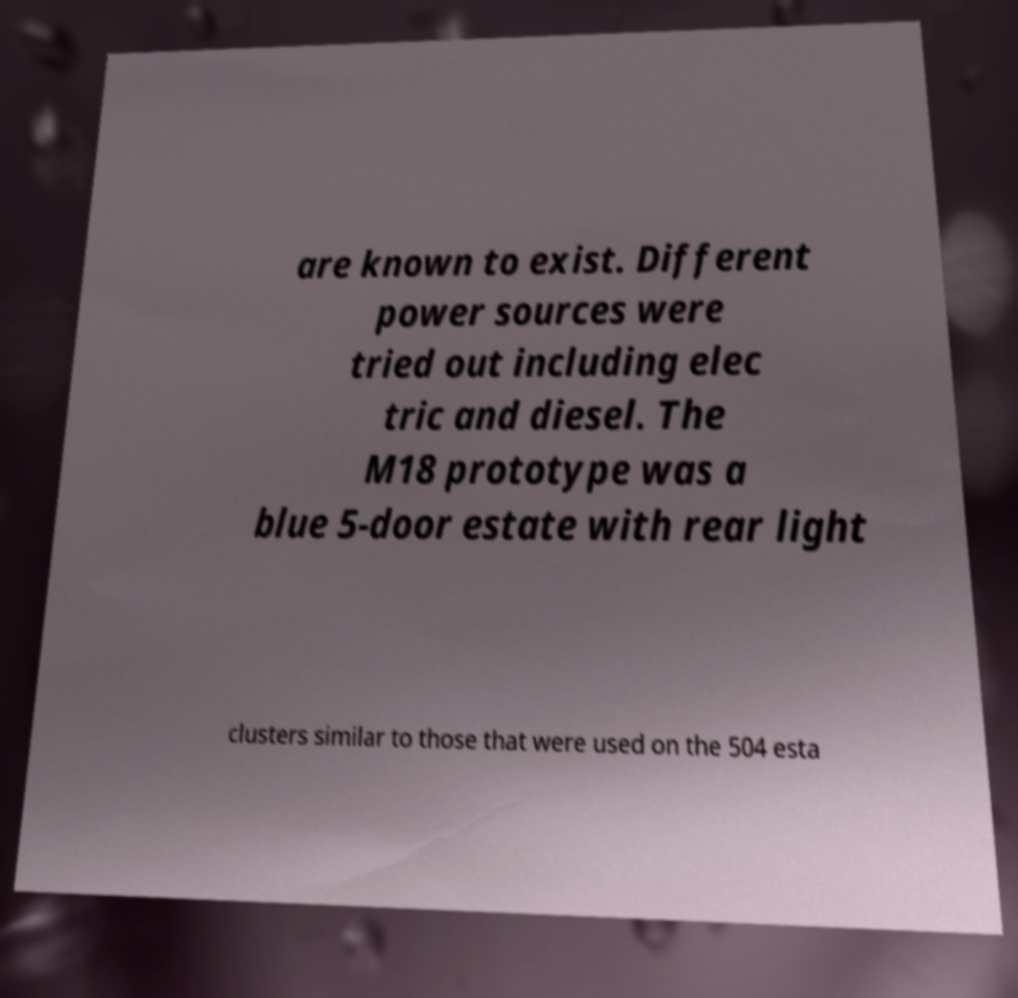Could you assist in decoding the text presented in this image and type it out clearly? are known to exist. Different power sources were tried out including elec tric and diesel. The M18 prototype was a blue 5-door estate with rear light clusters similar to those that were used on the 504 esta 